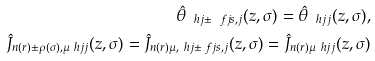Convert formula to latex. <formula><loc_0><loc_0><loc_500><loc_500>\hat { \theta } _ { \ h j \pm \ f j s , j } ( z , \sigma ) = \hat { \theta } _ { \ h j j } ( z , \sigma ) , \\ \hat { J } _ { n ( r ) \pm \rho ( \sigma ) , \mu \ h j j } ( z , \sigma ) = \hat { J } _ { n ( r ) \mu , \ h j \pm \ f j s , j } ( z , \sigma ) = \hat { J } _ { n ( r ) \mu \ h j j } ( z , \sigma )</formula> 